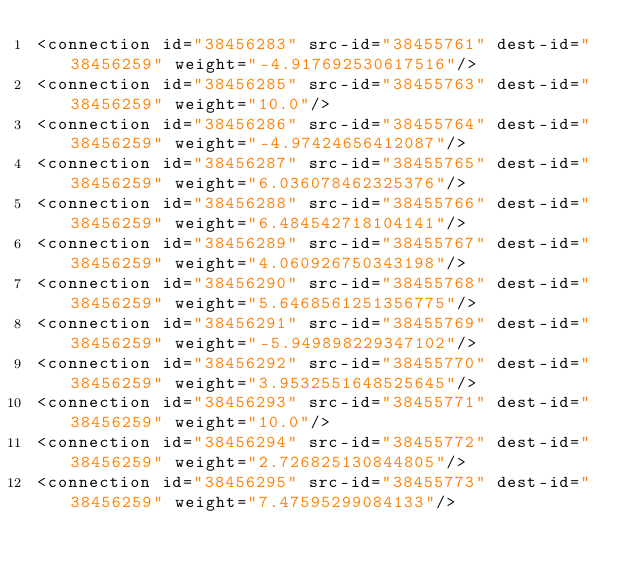Convert code to text. <code><loc_0><loc_0><loc_500><loc_500><_XML_><connection id="38456283" src-id="38455761" dest-id="38456259" weight="-4.917692530617516"/>
<connection id="38456285" src-id="38455763" dest-id="38456259" weight="10.0"/>
<connection id="38456286" src-id="38455764" dest-id="38456259" weight="-4.97424656412087"/>
<connection id="38456287" src-id="38455765" dest-id="38456259" weight="6.036078462325376"/>
<connection id="38456288" src-id="38455766" dest-id="38456259" weight="6.484542718104141"/>
<connection id="38456289" src-id="38455767" dest-id="38456259" weight="4.060926750343198"/>
<connection id="38456290" src-id="38455768" dest-id="38456259" weight="5.6468561251356775"/>
<connection id="38456291" src-id="38455769" dest-id="38456259" weight="-5.949898229347102"/>
<connection id="38456292" src-id="38455770" dest-id="38456259" weight="3.9532551648525645"/>
<connection id="38456293" src-id="38455771" dest-id="38456259" weight="10.0"/>
<connection id="38456294" src-id="38455772" dest-id="38456259" weight="2.726825130844805"/>
<connection id="38456295" src-id="38455773" dest-id="38456259" weight="7.47595299084133"/></code> 